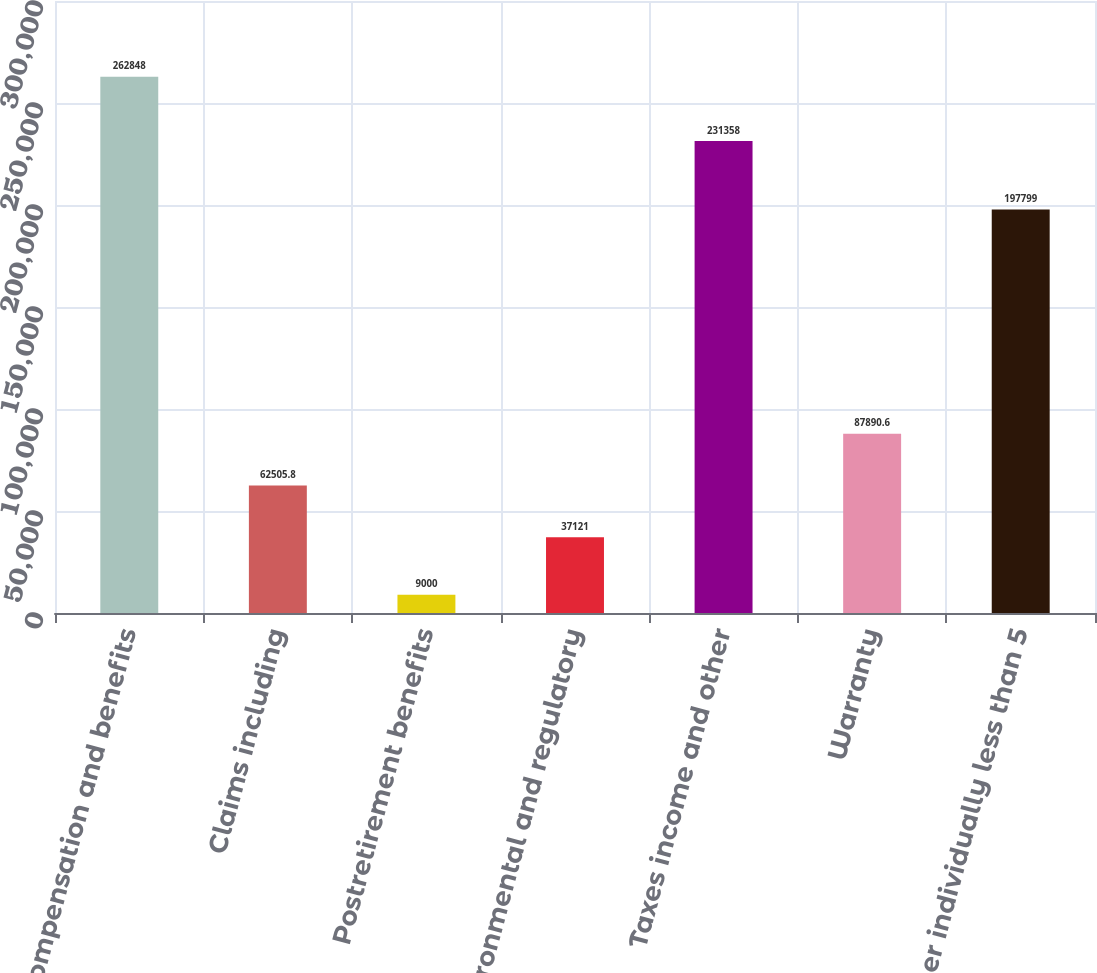<chart> <loc_0><loc_0><loc_500><loc_500><bar_chart><fcel>Compensation and benefits<fcel>Claims including<fcel>Postretirement benefits<fcel>Environmental and regulatory<fcel>Taxes income and other<fcel>Warranty<fcel>Other individually less than 5<nl><fcel>262848<fcel>62505.8<fcel>9000<fcel>37121<fcel>231358<fcel>87890.6<fcel>197799<nl></chart> 